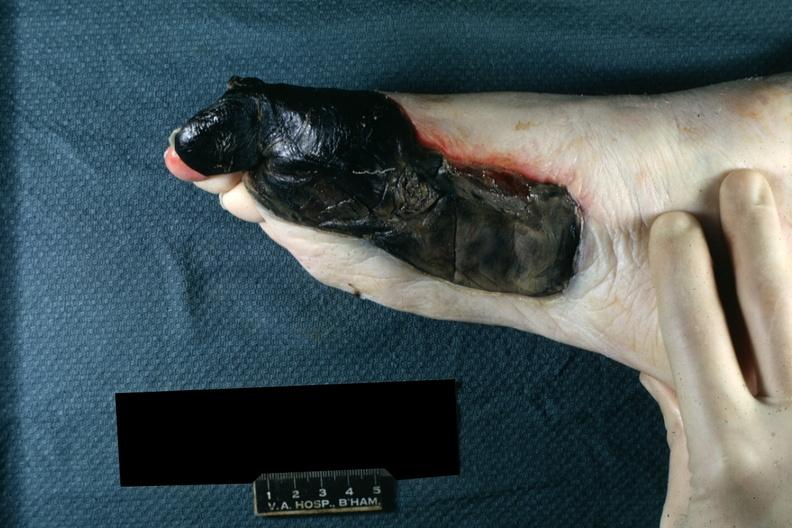what is medial aspect left?
Answer the question using a single word or phrase. Foot 